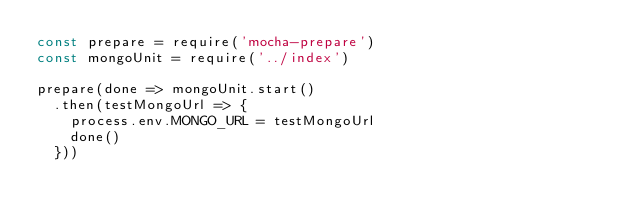<code> <loc_0><loc_0><loc_500><loc_500><_JavaScript_>const prepare = require('mocha-prepare')
const mongoUnit = require('../index')

prepare(done => mongoUnit.start()
  .then(testMongoUrl => {
    process.env.MONGO_URL = testMongoUrl
    done()
  }))
</code> 